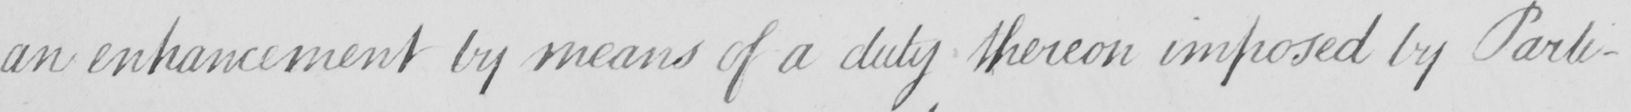Please provide the text content of this handwritten line. an enhancement by means of a duty thereon imposed by Parli- 